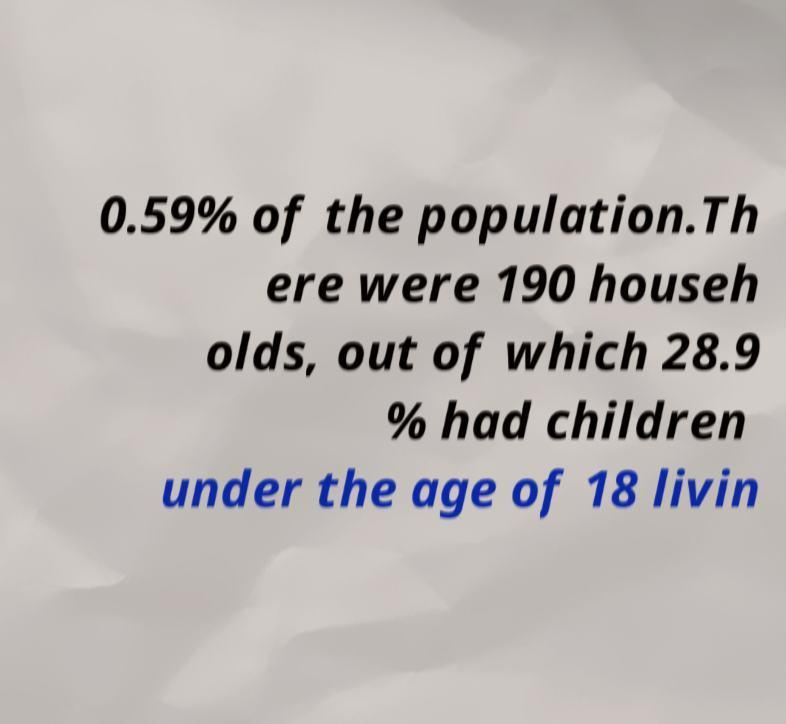There's text embedded in this image that I need extracted. Can you transcribe it verbatim? 0.59% of the population.Th ere were 190 househ olds, out of which 28.9 % had children under the age of 18 livin 